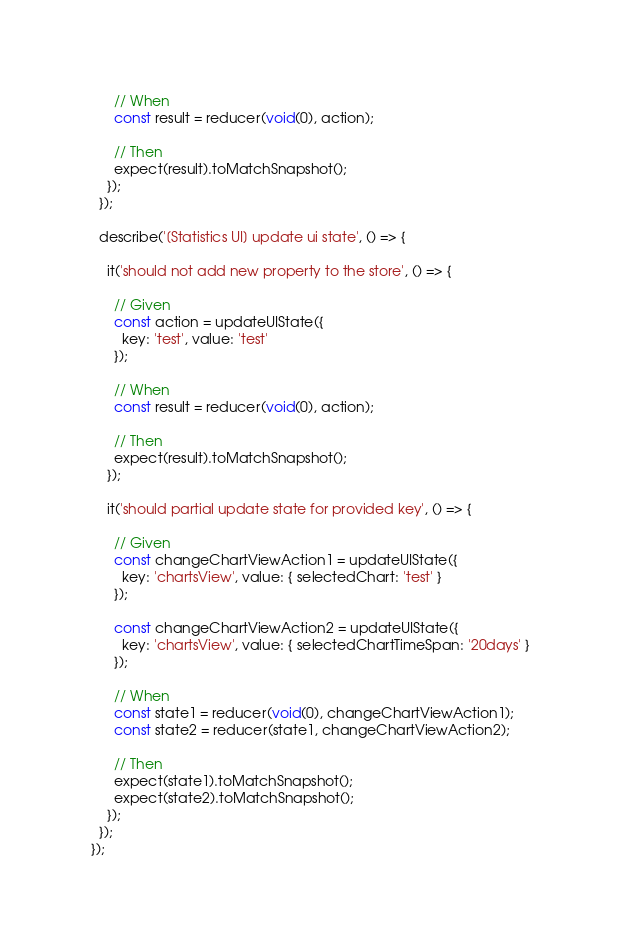<code> <loc_0><loc_0><loc_500><loc_500><_TypeScript_>
      // When
      const result = reducer(void(0), action);

      // Then
      expect(result).toMatchSnapshot();
    });
  });

  describe('[Statistics UI] update ui state', () => {

    it('should not add new property to the store', () => {

      // Given
      const action = updateUIState({
        key: 'test', value: 'test'
      });

      // When
      const result = reducer(void(0), action);

      // Then
      expect(result).toMatchSnapshot();
    });

    it('should partial update state for provided key', () => {

      // Given
      const changeChartViewAction1 = updateUIState({
        key: 'chartsView', value: { selectedChart: 'test' }
      });

      const changeChartViewAction2 = updateUIState({
        key: 'chartsView', value: { selectedChartTimeSpan: '20days' }
      });

      // When
      const state1 = reducer(void(0), changeChartViewAction1);
      const state2 = reducer(state1, changeChartViewAction2);

      // Then
      expect(state1).toMatchSnapshot();
      expect(state2).toMatchSnapshot();
    });
  });
});
</code> 